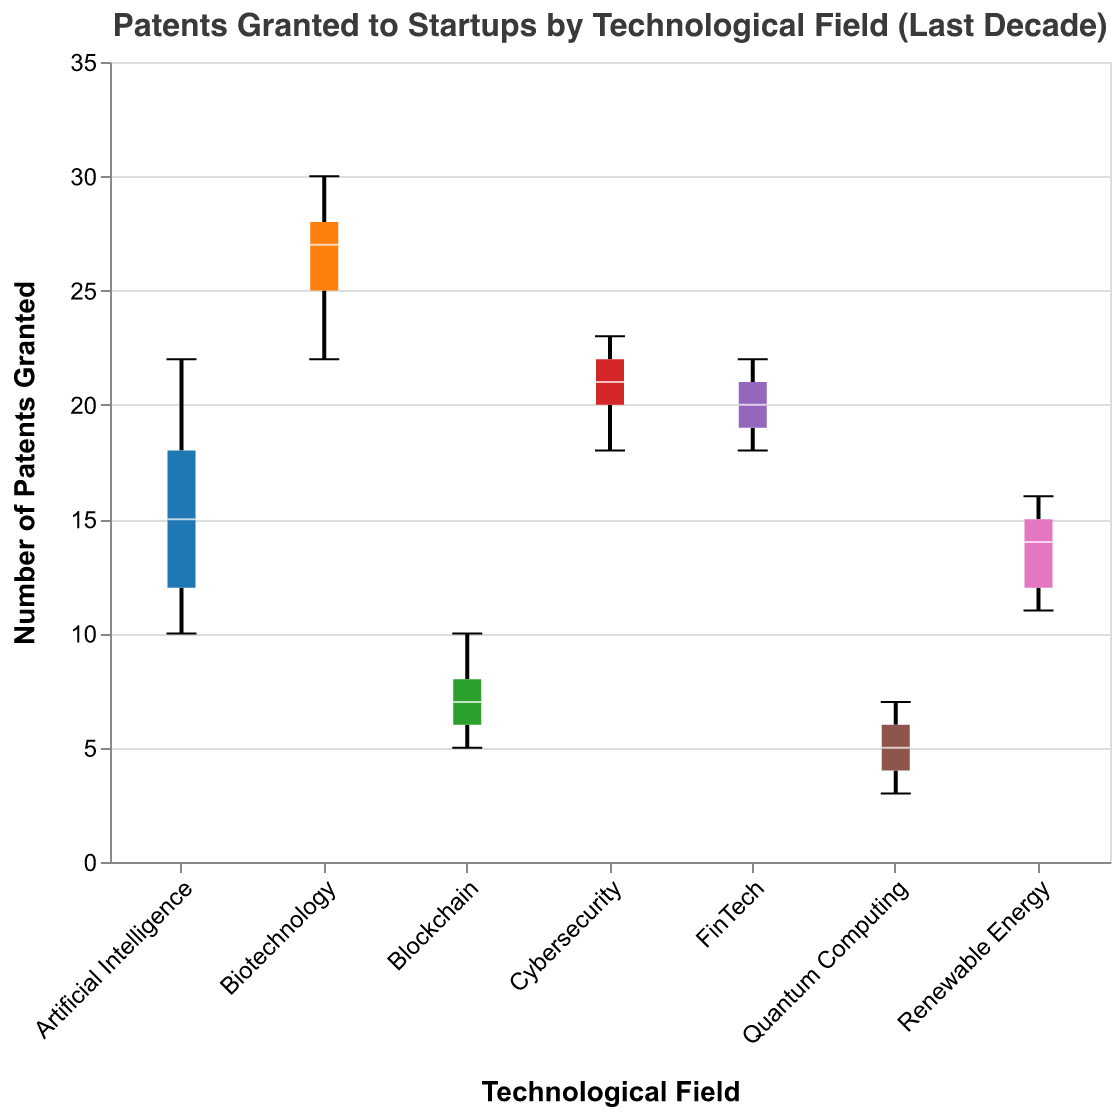What is the title of the figure? The title is displayed at the top of the figure and reads "Patents Granted to Startups by Technological Field (Last Decade)"
Answer: Patents Granted to Startups by Technological Field (Last Decade) What is the range of patents granted for the Blockchain field? The whiskers and the notches of the box plot for Blockchain indicate the minimum and maximum values. The range can be seen from the bottom whisker (5) to the top whisker (10).
Answer: 5 to 10 Which technological field has the highest median number of patents granted? Locate the middle line (median) inside each box plot. The Biotechnology field has the highest median since its line is the highest among all fields.
Answer: Biotechnology Which field has the widest spread of patents granted? To determine the spread, observe the length of the boxes and whiskers. Biotechnology has the widest spread, indicated by its extended whiskers and a tall box.
Answer: Biotechnology How do the median values of FinTech and Cybersecurity compare? Identify the median lines for both FinTech and Cybersecurity. FinTech and Cybersecurity have almost identical median values, making it hard to distinguish them visually.
Answer: They are nearly equal What is the interquartile range (IQR) for Artificial Intelligence? The IQR is the distance between the top and bottom edges of the box. For Artificial Intelligence, the lower quartile (Q1) appears around 12, and the upper quartile (Q3) around 18. Thus, IQR = Q3 - Q1 = 18 - 12.
Answer: 6 Which technological field has the most concentrated number of patents granted, with less spread? By observing the box sizes and whisker lengths, Quantum Computing has the least spread, indicated by a small box and short whiskers.
Answer: Quantum Computing Which field has the largest number of patents granted as an outlier? An outlier is represented by a data point outside the whiskers. Here, we assume there are no explicit outliers displayed for exact outlier identification. However, if 'extreme values' were present beyond whiskers, we would identify accordingly.
Answer: Not explicitly shown Are there any fields where the interquartile ranges do not overlap? Notched box plots can show this; non-overlapping notches usually signify statistical differences. The fields FinTech and Quantum Computing have non-overlapping notches with other fields, suggesting distinct medians.
Answer: FinTech and Quantum Computing What is the minimum number of patents granted in the Renewable Energy field? The minimum value is indicated by the bottom whisker of the box plot for Renewable Energy, which extends to 11.
Answer: 11 